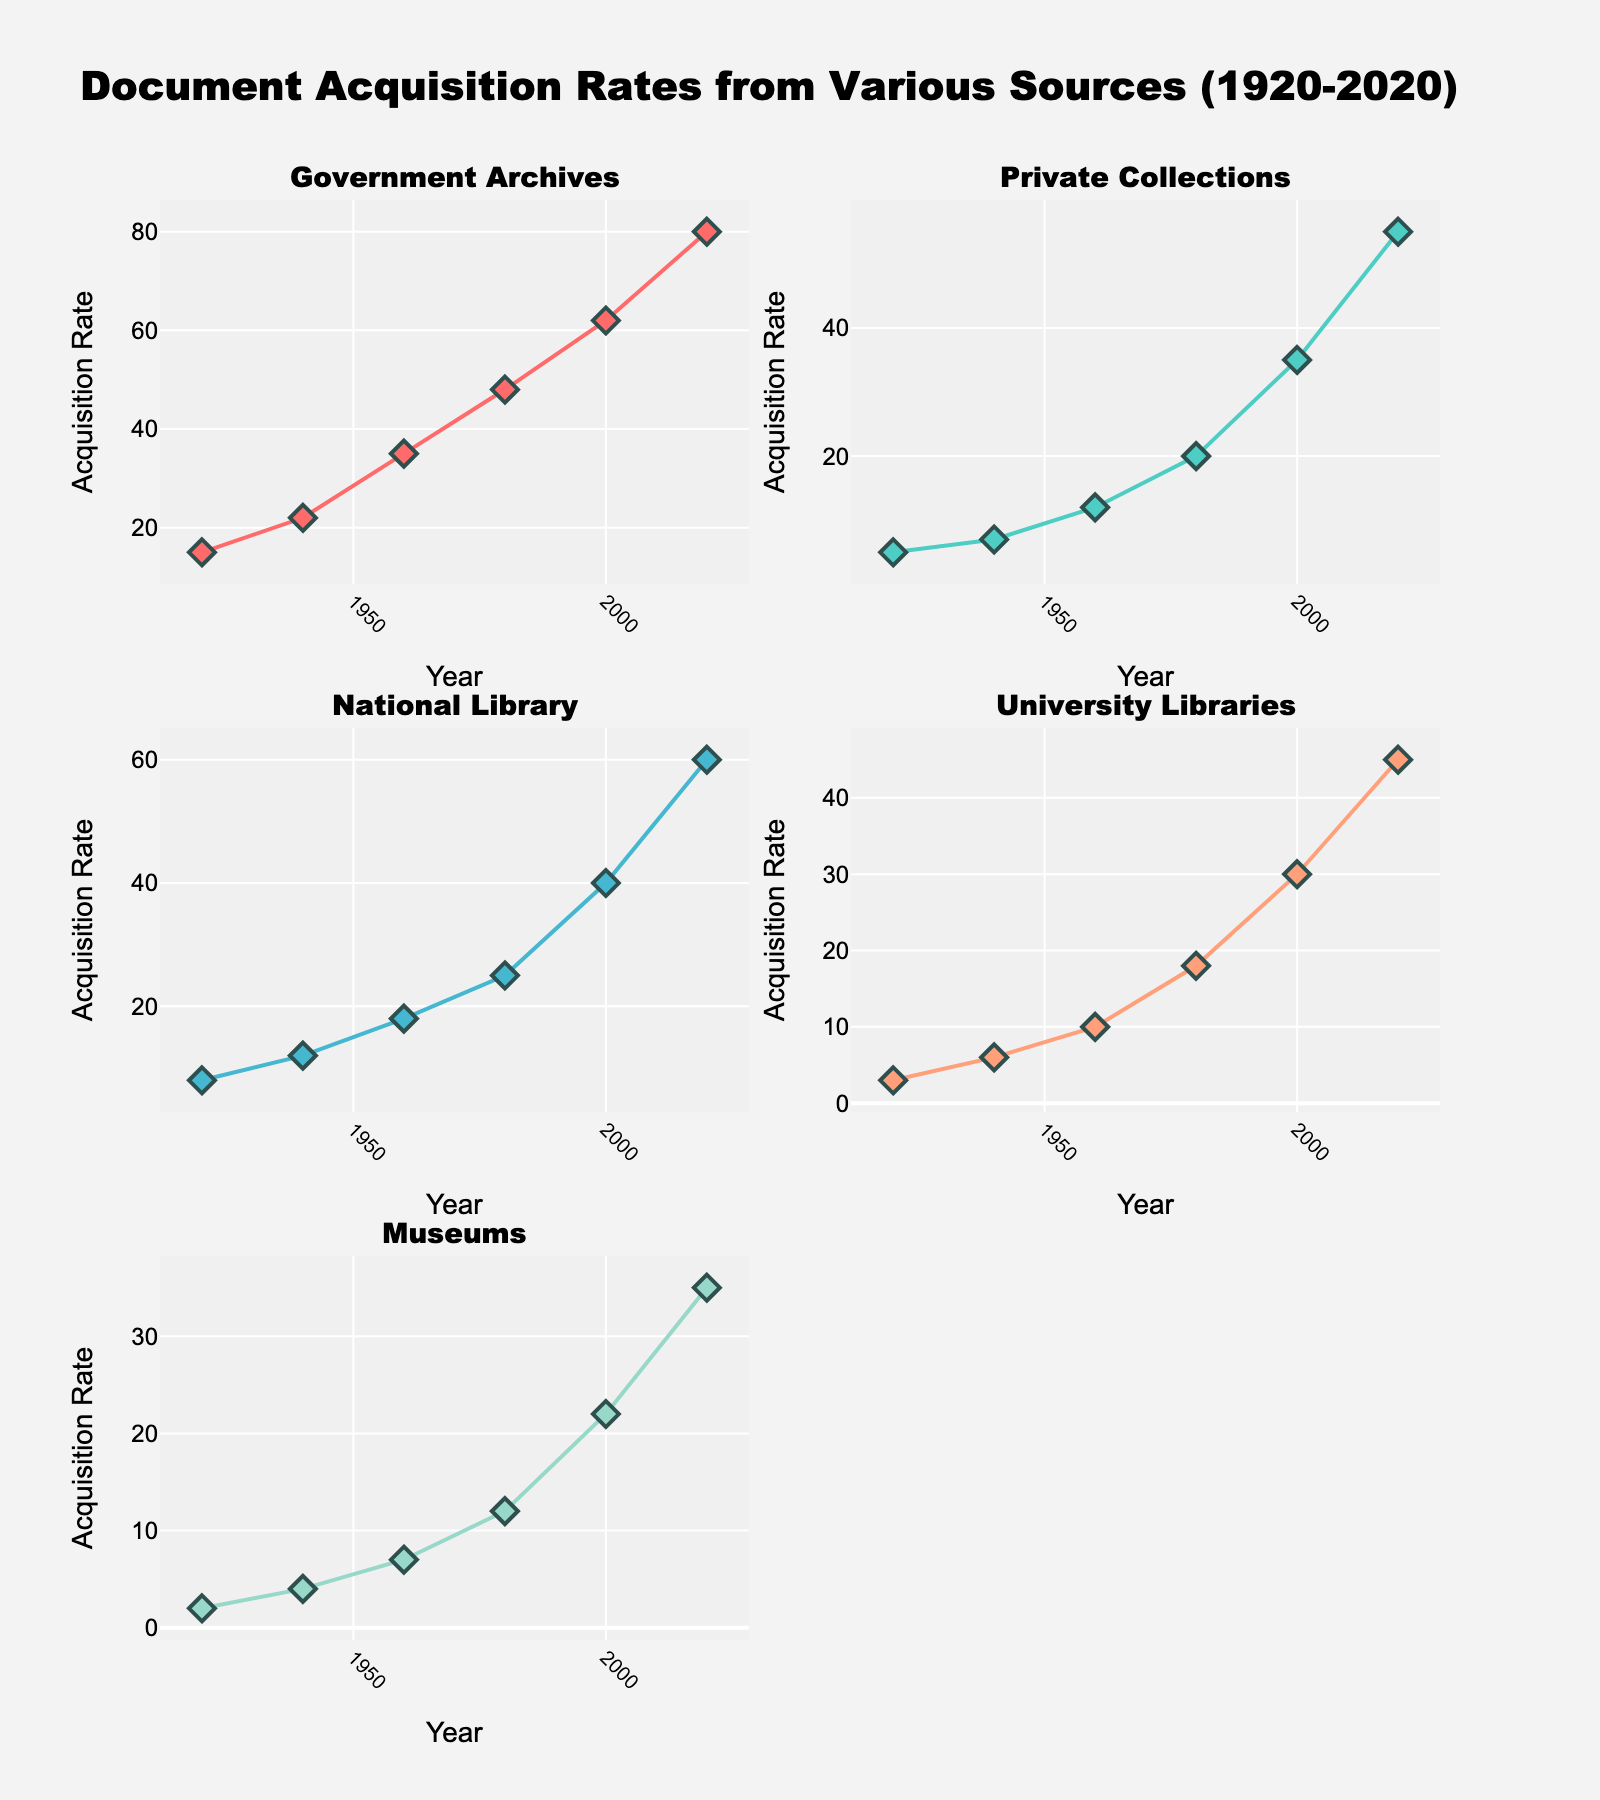What are the two sources of support most sought by teens? The pie chart for teens shows the percentages for each source of support. The two largest slices correspond to Parents and Friends, with percentages of 35% and 25%, respectively.
Answer: Parents and Friends Which source of support has the smallest percentage for both age groups? For teens, the smallest percentage is 5% for Helplines. For young adults, the smallest percentage is 10% for Family Members.
Answer: Helplines for teens and Family Members for young adults Is there a source of support that is equally sought by both teens and young adults? Comparing the percentages of each source for both age groups, there doesn't appear to be any source with the same percentage.
Answer: No What is the difference in support sought from online platforms (Online Support Groups and Online Forums) between the two age groups? Teens: 15% (Online Support Groups). Young Adults: 20% (Online Forums). The difference is 20% - 15%.
Answer: 5% How many sources of support are displayed for each age group? Both pie charts show segments representing the different sources of support. Teens have Parents, Friends, School Counselors, Online Support Groups, and Helplines, totaling 5 sources. Young Adults have Friends, University Counseling Services, Online Forums, Mental Health Professionals, and Family Members, also totaling 5 sources.
Answer: 5 Which source of support has the highest percentage difference between the two age groups? Calculate the percentage difference for each support source between the two age groups. For example, Friends: 30% (Young Adults) - 25% (Teens) = 5%. Comparing all differences, the highest difference is between Parents (Teens: 35%, Young Adults: 0%) and University Counseling Services (Young Adults: 25%, Teens: 0%).
Answer: Parents Which source has the highest percentage among young adults? The pie chart for young adults shows the Friends segment as the largest, with a percentage of 30%.
Answer: Friends What is the combined percentage of support sought from family-related sources among young adults (Family Members and Friends)? Friends: 30%, Family Members: 10%. Combine them: 30% + 10% = 40%.
Answer: 40% How many sources have a higher percentage among young adults compared to teens? Comparing each source between the two age groups, Friends (30% vs 25%) and University Counseling Services (25% vs 0%) are higher, totaling 2 sources.
Answer: 2 Are school-based support sources (School Counselors for teens and University Counseling Services for young adults) more sought by one age group? Compare percentages of School Counselors for teens (20%) and University Counseling Services for young adults (25%). University Counseling Services has a higher percentage.
Answer: Yes, young adults 